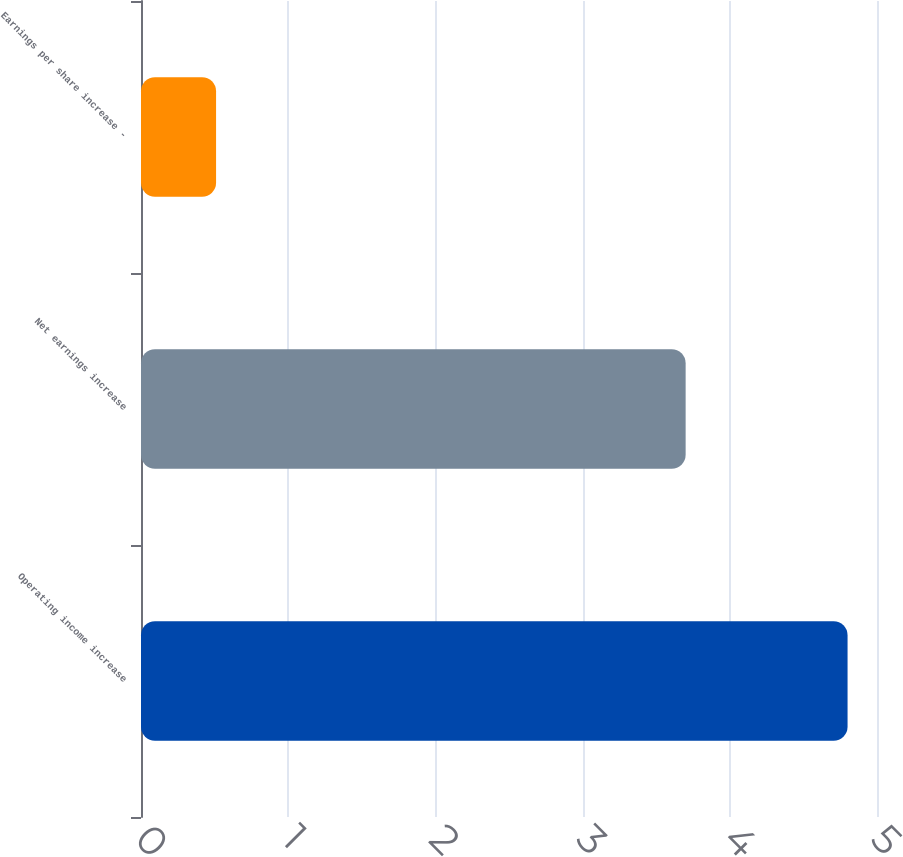<chart> <loc_0><loc_0><loc_500><loc_500><bar_chart><fcel>Operating income increase<fcel>Net earnings increase<fcel>Earnings per share increase -<nl><fcel>4.8<fcel>3.7<fcel>0.51<nl></chart> 